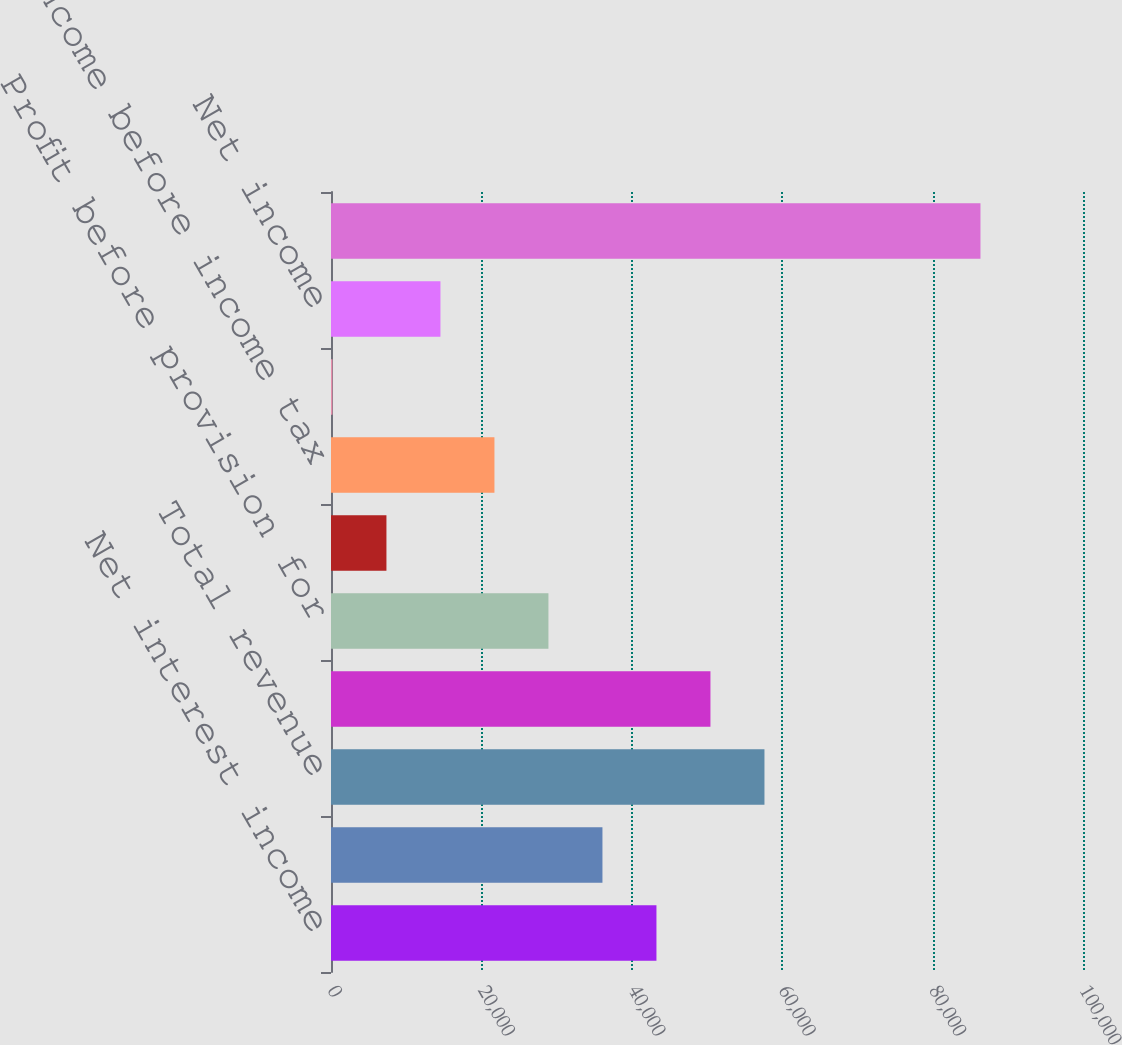<chart> <loc_0><loc_0><loc_500><loc_500><bar_chart><fcel>Net interest income<fcel>Noninterest income<fcel>Total revenue<fcel>Noninterest expense<fcel>Profit before provision for<fcel>Provision for credit losses<fcel>Income before income tax<fcel>Income tax expense<fcel>Net income<fcel>Loans and leases and loans<nl><fcel>43278.2<fcel>36097<fcel>57640.6<fcel>50459.4<fcel>28915.8<fcel>7372.2<fcel>21734.6<fcel>191<fcel>14553.4<fcel>86365.4<nl></chart> 